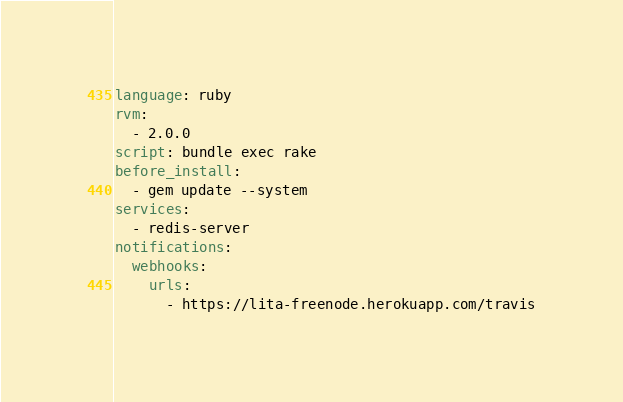<code> <loc_0><loc_0><loc_500><loc_500><_YAML_>language: ruby
rvm:
  - 2.0.0
script: bundle exec rake
before_install:
  - gem update --system
services:
  - redis-server
notifications:
  webhooks:
    urls:
      - https://lita-freenode.herokuapp.com/travis
</code> 